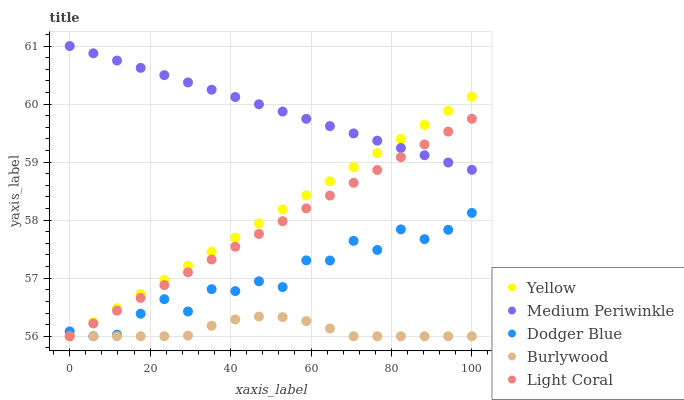Does Burlywood have the minimum area under the curve?
Answer yes or no. Yes. Does Medium Periwinkle have the maximum area under the curve?
Answer yes or no. Yes. Does Dodger Blue have the minimum area under the curve?
Answer yes or no. No. Does Dodger Blue have the maximum area under the curve?
Answer yes or no. No. Is Medium Periwinkle the smoothest?
Answer yes or no. Yes. Is Dodger Blue the roughest?
Answer yes or no. Yes. Is Light Coral the smoothest?
Answer yes or no. No. Is Light Coral the roughest?
Answer yes or no. No. Does Burlywood have the lowest value?
Answer yes or no. Yes. Does Medium Periwinkle have the lowest value?
Answer yes or no. No. Does Medium Periwinkle have the highest value?
Answer yes or no. Yes. Does Dodger Blue have the highest value?
Answer yes or no. No. Is Burlywood less than Medium Periwinkle?
Answer yes or no. Yes. Is Medium Periwinkle greater than Dodger Blue?
Answer yes or no. Yes. Does Burlywood intersect Yellow?
Answer yes or no. Yes. Is Burlywood less than Yellow?
Answer yes or no. No. Is Burlywood greater than Yellow?
Answer yes or no. No. Does Burlywood intersect Medium Periwinkle?
Answer yes or no. No. 